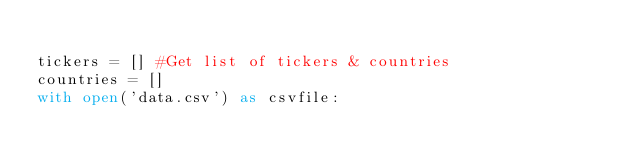<code> <loc_0><loc_0><loc_500><loc_500><_Python_>
tickers = [] #Get list of tickers & countries
countries = []
with open('data.csv') as csvfile:</code> 